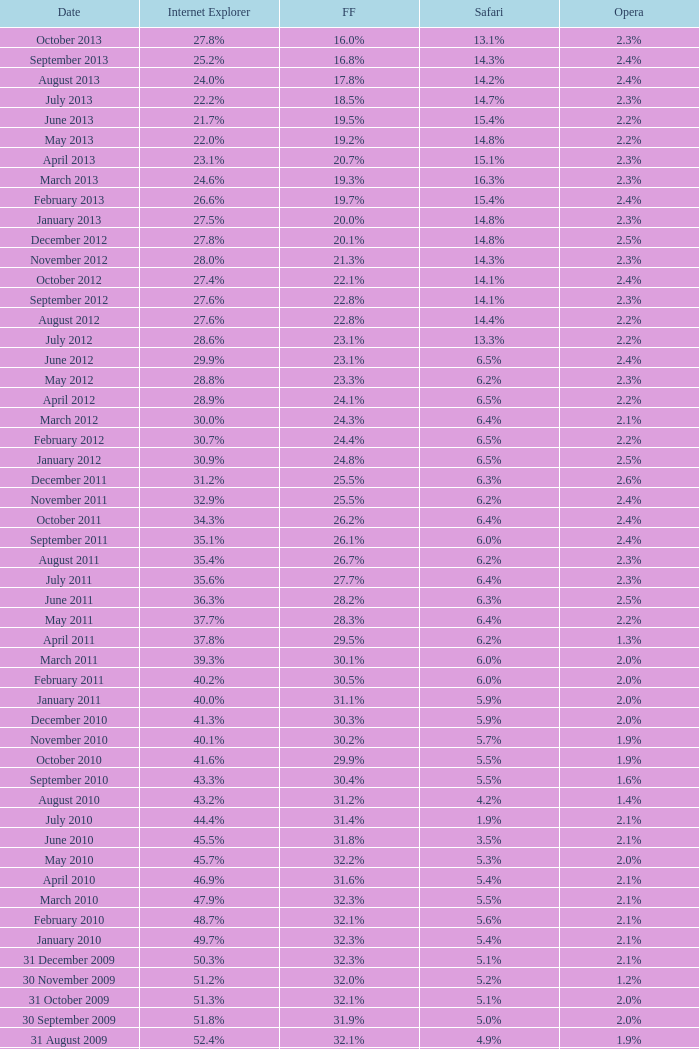9% safari? 31.4%. 